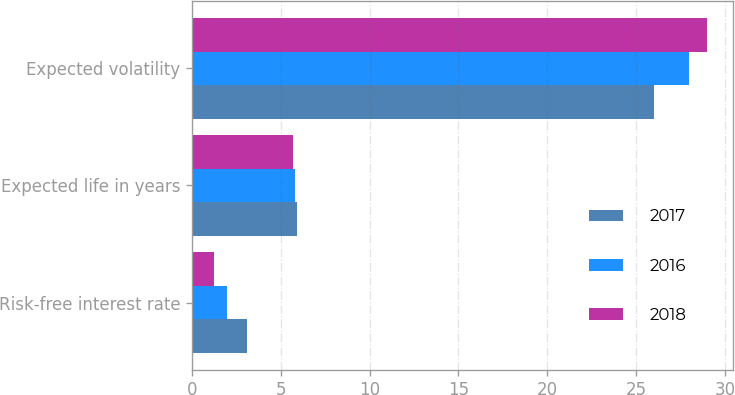Convert chart. <chart><loc_0><loc_0><loc_500><loc_500><stacked_bar_chart><ecel><fcel>Risk-free interest rate<fcel>Expected life in years<fcel>Expected volatility<nl><fcel>2017<fcel>3.09<fcel>5.9<fcel>26<nl><fcel>2016<fcel>2<fcel>5.8<fcel>28<nl><fcel>2018<fcel>1.26<fcel>5.7<fcel>29<nl></chart> 